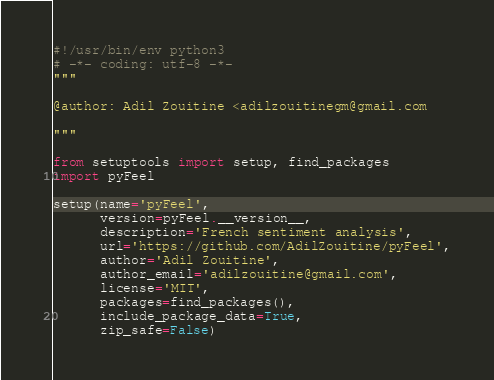Convert code to text. <code><loc_0><loc_0><loc_500><loc_500><_Python_>#!/usr/bin/env python3
# -*- coding: utf-8 -*-
"""

@author: Adil Zouitine <adilzouitinegm@gmail.com

"""

from setuptools import setup, find_packages
import pyFeel

setup(name='pyFeel',
      version=pyFeel.__version__,
      description='French sentiment analysis',
      url='https://github.com/AdilZouitine/pyFeel',
      author='Adil Zouitine',
      author_email='adilzouitine@gmail.com',
      license='MIT',
      packages=find_packages(),
      include_package_data=True,
      zip_safe=False)
</code> 